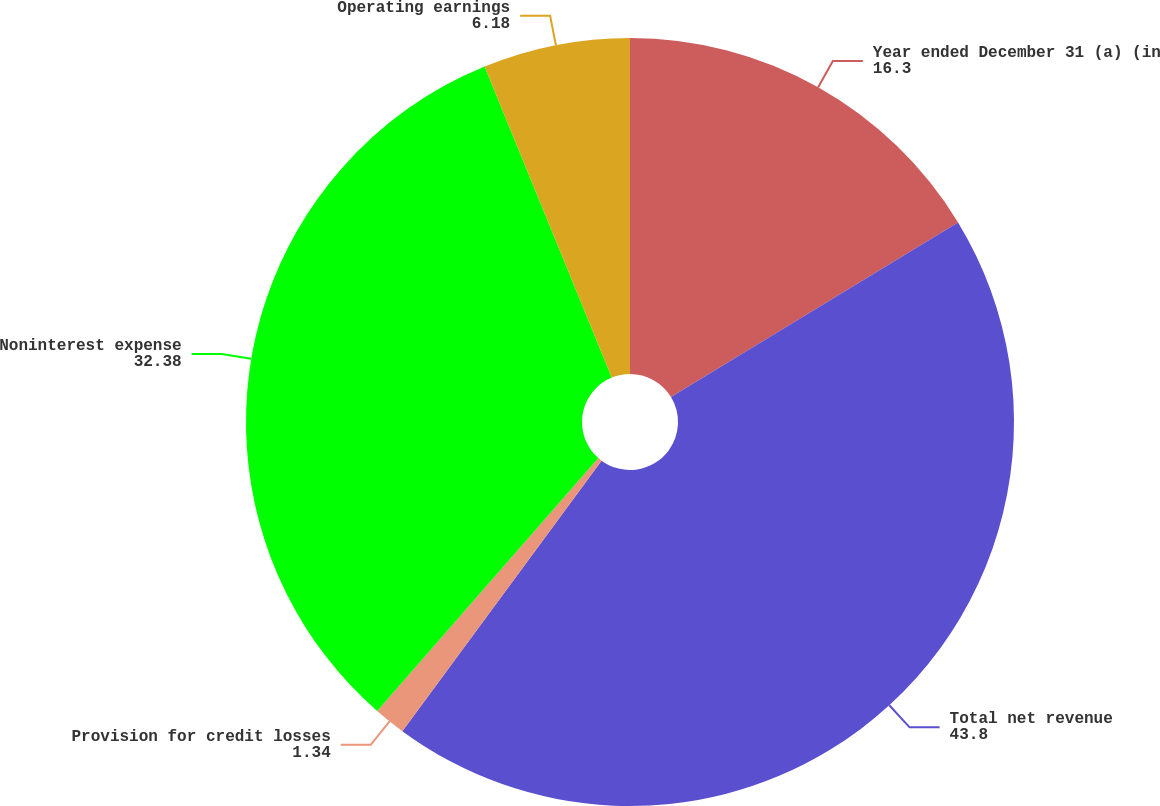Convert chart. <chart><loc_0><loc_0><loc_500><loc_500><pie_chart><fcel>Year ended December 31 (a) (in<fcel>Total net revenue<fcel>Provision for credit losses<fcel>Noninterest expense<fcel>Operating earnings<nl><fcel>16.3%<fcel>43.8%<fcel>1.34%<fcel>32.38%<fcel>6.18%<nl></chart> 